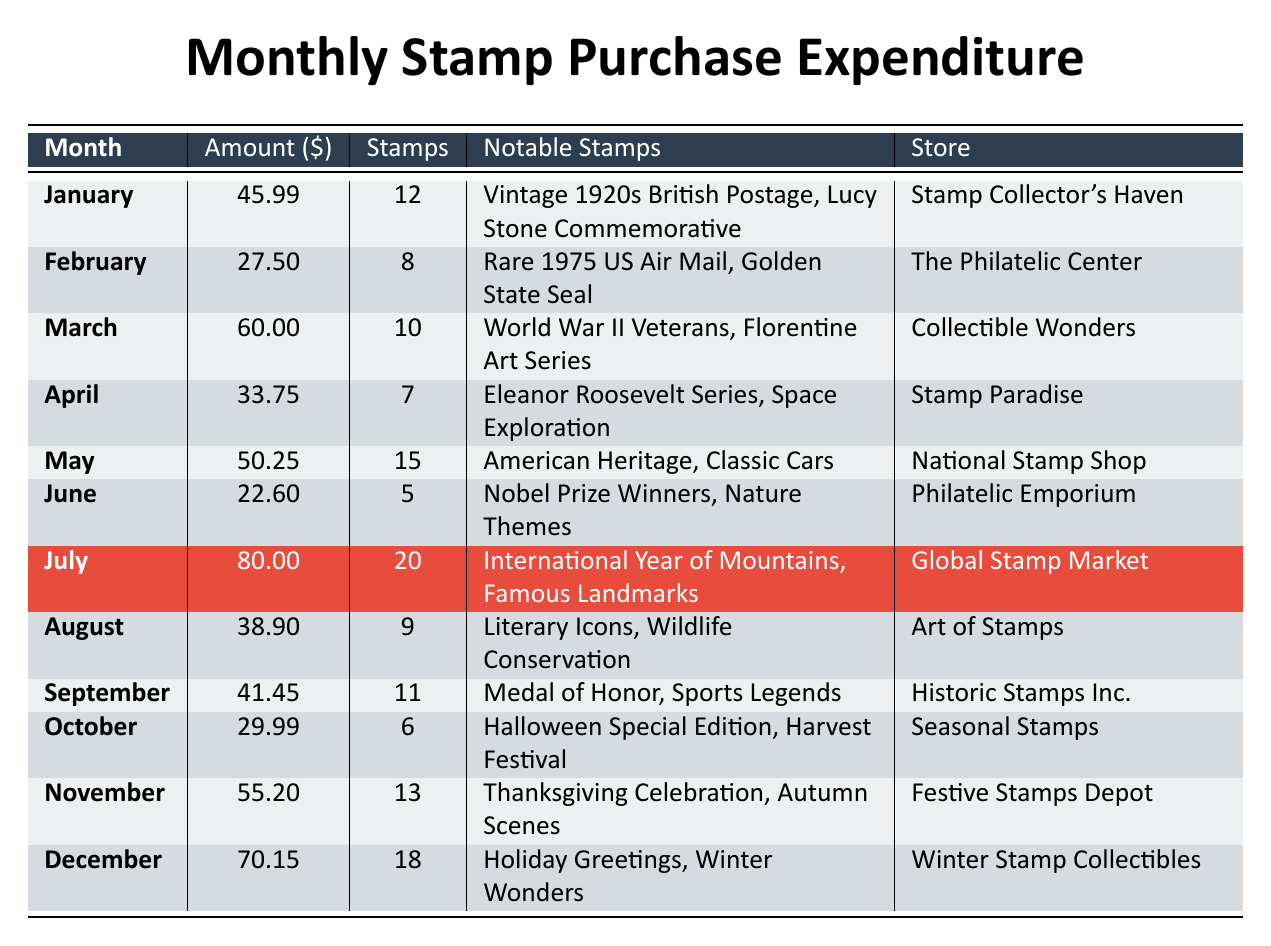What is the total amount spent on stamp purchases in December? The table shows that the amount spent in December is $70.15.
Answer: 70.15 Which month had the highest expenditure on stamp purchases? By reviewing the amounts in the table, July has the highest expenditure at $80.00.
Answer: July How many stamps were purchased in May? The table indicates that 15 stamps were purchased in May.
Answer: 15 What are the notable stamps purchased in March? According to the table, the notable stamps for March are "World War II Veterans" and "Florentine Art Series."
Answer: World War II Veterans, Florentine Art Series What is the average monthly expenditure on stamps for the year? The total amount spent is $70.15 + $55.20 + $29.99 + $41.45 + $38.90 + $80.00 + $22.60 + $50.25 + $60.00 + $33.75 + $27.50 + $45.99 = $ 538.64. Dividing by 12 months gives an average of $44.89.
Answer: 44.89 In which month was the least amount spent on stamp purchases? The table shows that June has the least expenditure of $22.60.
Answer: June How many total stamps were purchased throughout the year? To find the total, we add the stamps purchased each month: 12 + 8 + 10 + 7 + 15 + 5 + 20 + 9 + 11 + 6 + 13 + 18 =  144.
Answer: 144 Did more stamps get purchased in November compared to February? The table states that 13 stamps were purchased in November and 8 in February, so yes, more stamps were purchased in November.
Answer: Yes What is the difference in the amount spent between the months of March and April? The amount spent in March is $60.00 and in April is $33.75. The difference is $60.00 - $33.75 = $26.25.
Answer: 26.25 What notable stamps were purchased in August? According to the table, the notable stamps for August were "Literary Icons" and "Wildlife Conservation."
Answer: Literary Icons, Wildlife Conservation Was the expenditure on stamps in July significantly higher than the average monthly expenditure? The average is $44.89 and July's expenditure is $80.00, which is significantly higher than the average.
Answer: Yes 